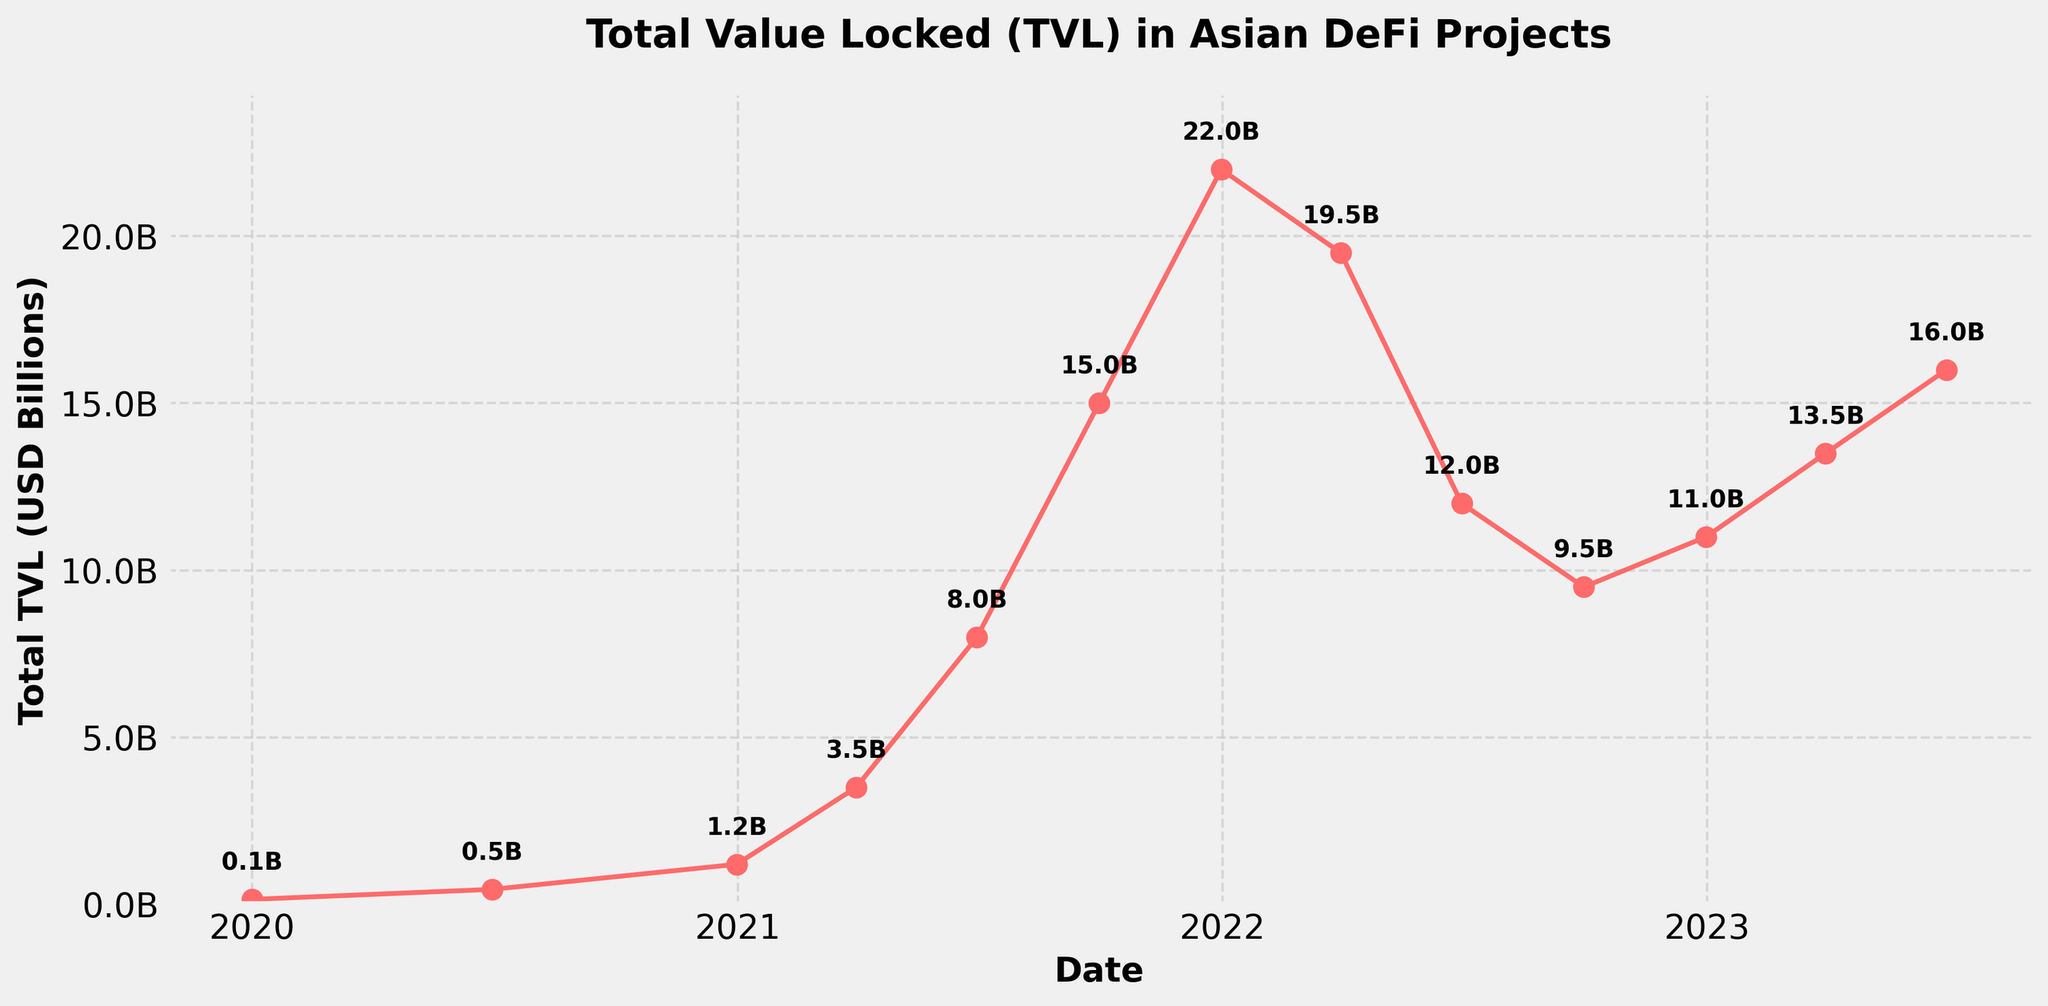What's the peak TVL value in the data? The highest point on the line chart indicates the peak TVL. It's at the end of 2021, where the total TVL reaches around $22,000 million.
Answer: $22,000 million How much did the TVL increase from January 2020 to December 2020? The TVL in January 2020 was $150 million. By December 2020, it increased to $1,200 million. The difference is $1,200 million - $150 million = $1,050 million.
Answer: $1,050 million What was the approximate percentage decrease in TVL from December 2021 to June 2022? In December 2021, the TVL was $22,000 million and in June 2022, it dropped to $12,000 million. The percentage decrease is calculated as ((22,000 - 12,000) / 22,000) * 100 ≈ 45.45%.
Answer: ~45.45% During which period did the TVL experience the most significant growth? The period from June 2021 to September 2021 saw a significant rise from $8,000 million to $15,000 million, the largest growth within three months.
Answer: June 2021 to September 2021 Compare the TVL values in March 2021 and March 2023. How much did it change? In March 2021, the TVL was $3,500 million. In March 2023, the TVL was $13,500 million. The change is $13,500 million - $3,500 million = $10,000 million.
Answer: $10,000 million Which year had the highest average TVL? Calculate the average TVL for each year. For 2021, sum the values and divide by 4 quarters: (1200 + 3500 + 8000 + 15000) / 4 = $6,425 million. For 2022, sum the values and divide by 4 quarters: (22000 + 19500 + 12000 + 9500) / 4 = $15,500 million. For 2023, sum the values and divide by 2 quarters (since there are only 2 data points in 2023): (11000 + 13500 + 16000) / 3 = $13,500 million. Therefore, 2022 had the highest average TVL at approximately $15,500 million.
Answer: 2022 Visually, what is the trend observed from January 2020 to June 2023? The line chart shows a general upward trend with fluctuations. From a low in January 2020, it peaks at the end of 2021, then drops in 2022, and slightly recovers into 2023.
Answer: Upward trend with fluctuations What is the average TVL for the whole dataset? Sum all the TVL values and divide by the number of data points: (150 + 450 + 1200 + 3500 + 8000 + 15000 + 22000 + 19500 + 12000 + 9500 + 11000 + 13500 + 16000) / 13 ≈ $10,085 million.
Answer: ~$10,085 million How does the TVL in December 2022 compare to December 2021? In December 2021, the TVL was $22,000 million. By December 2022, it had decreased to $11,000 million. The December 2022 TVL is exactly half of December 2021.
Answer: Half 